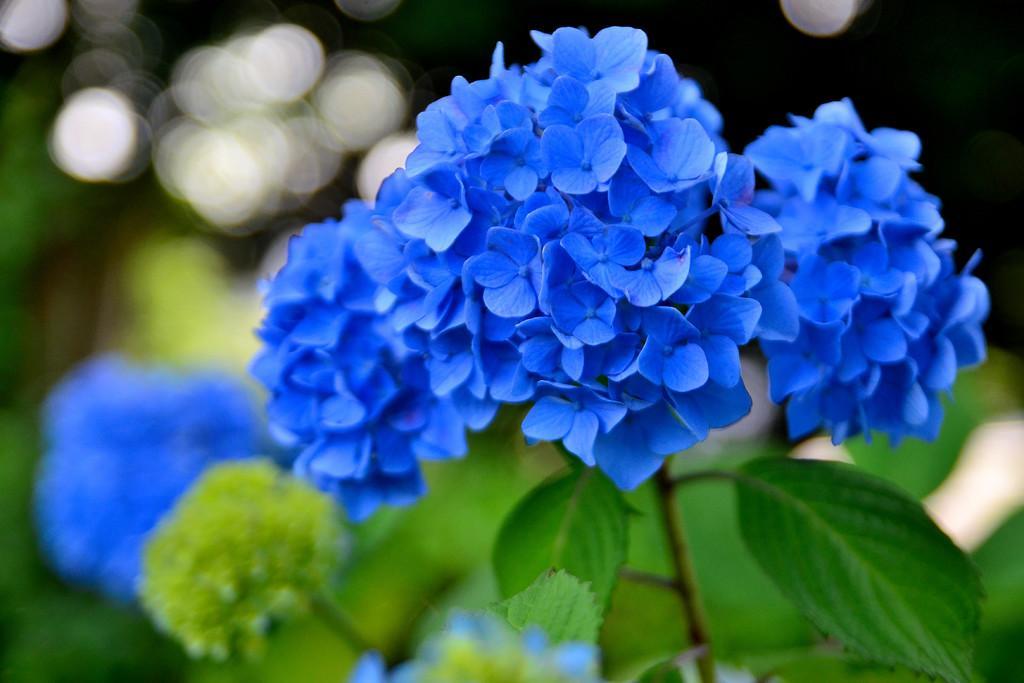Can you describe this image briefly? In the middle of this image, there are blue color flowers of a plant having green color leaves. And the background is blurred. 